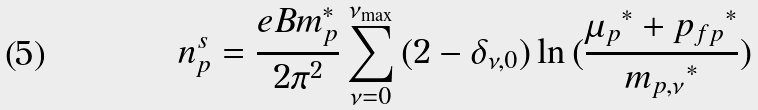<formula> <loc_0><loc_0><loc_500><loc_500>n _ { p } ^ { s } = \frac { e B { m _ { p } ^ { * } } } { 2 { \pi } ^ { 2 } } \sum _ { \nu = 0 } ^ { \nu _ { \max } } { ( 2 - { \delta } _ { { \nu } , 0 } ) } \ln { ( \frac { { { \mu } _ { p } } ^ { * } + { p _ { f p } } ^ { * } } { { m _ { p , { \nu } } } ^ { * } } ) }</formula> 